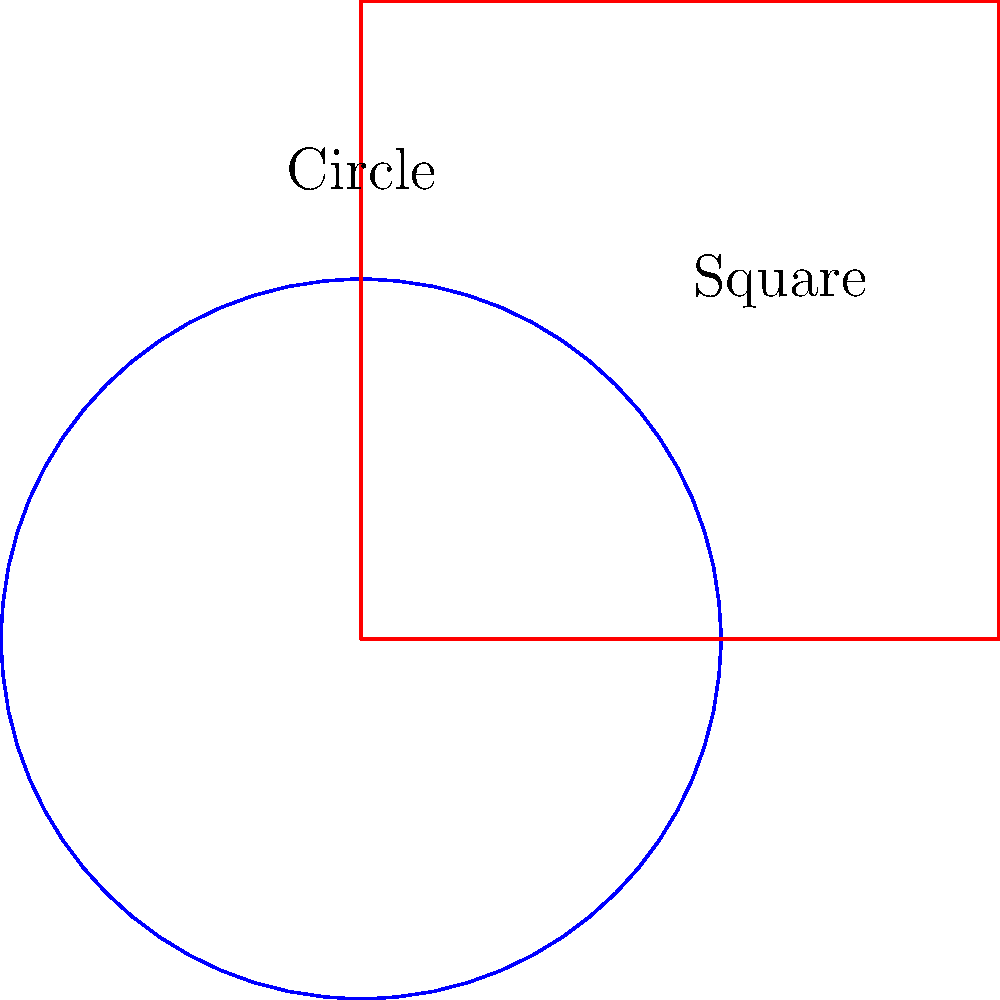In the context of homotopy equivalence, which of the following statements is true about the relationship between the circle and square shown in the diagram?

A) The circle and square are not homotopy equivalent.
B) The circle and square are homotopy equivalent, but not homeomorphic.
C) The circle and square are both homotopy equivalent and homeomorphic.
D) The circle and square are homeomorphic, but not homotopy equivalent. To answer this question, let's follow these steps:

1) First, recall the definitions:
   - Two spaces are homotopy equivalent if they can be continuously deformed into each other.
   - Two spaces are homeomorphic if there exists a continuous bijection between them with a continuous inverse.

2) Consider the circle and square:
   - They can both be continuously deformed into each other. For example, we can "inflate" the square to make it round, or "squish" the circle to make it square-like.
   - This continuous deformation means they are homotopy equivalent.

3) However, they are not homeomorphic:
   - The circle is smooth everywhere, while the square has four distinct corners.
   - There's no way to create a continuous bijection that preserves these local properties.

4) In topology, homotopy equivalence is a weaker condition than homeomorphism:
   - All homeomorphic spaces are homotopy equivalent, but not all homotopy equivalent spaces are homeomorphic.

5) Looking at our options:
   A) is false, as they are homotopy equivalent.
   B) is correct, as it accurately describes their relationship.
   C) is false, as they are not homeomorphic.
   D) is false, as they are homotopy equivalent.

Therefore, the correct answer is B: The circle and square are homotopy equivalent, but not homeomorphic.
Answer: B 